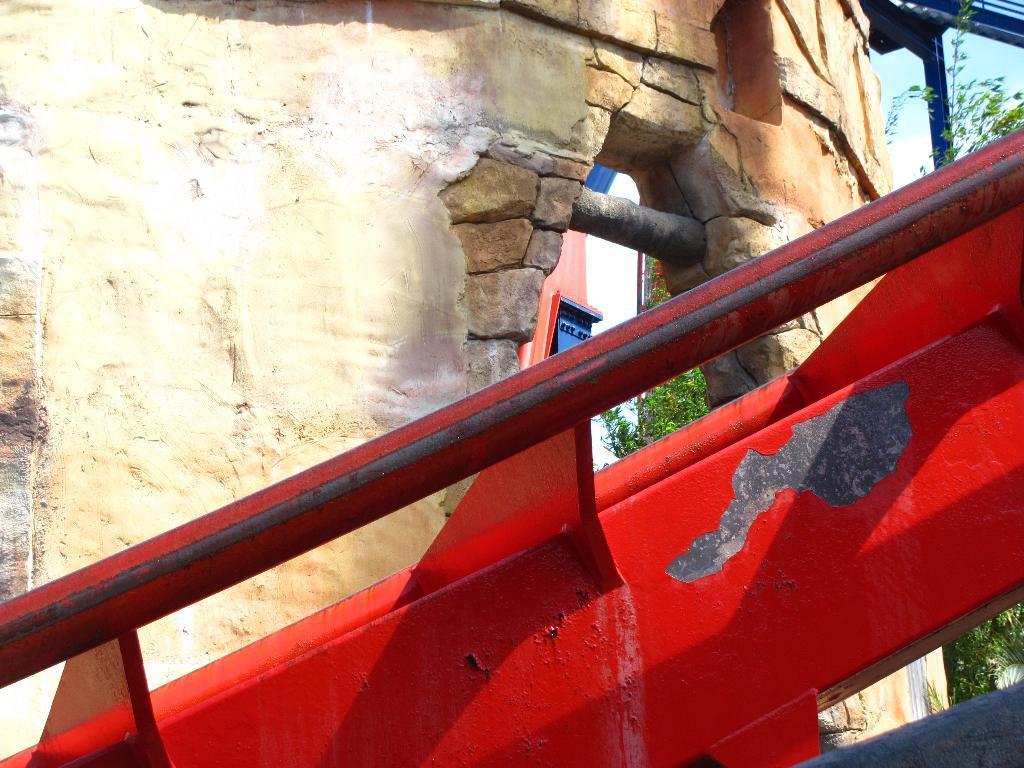Describe this image in one or two sentences. In this image there is an object and a wall. In the background there is a tree and a sky. 